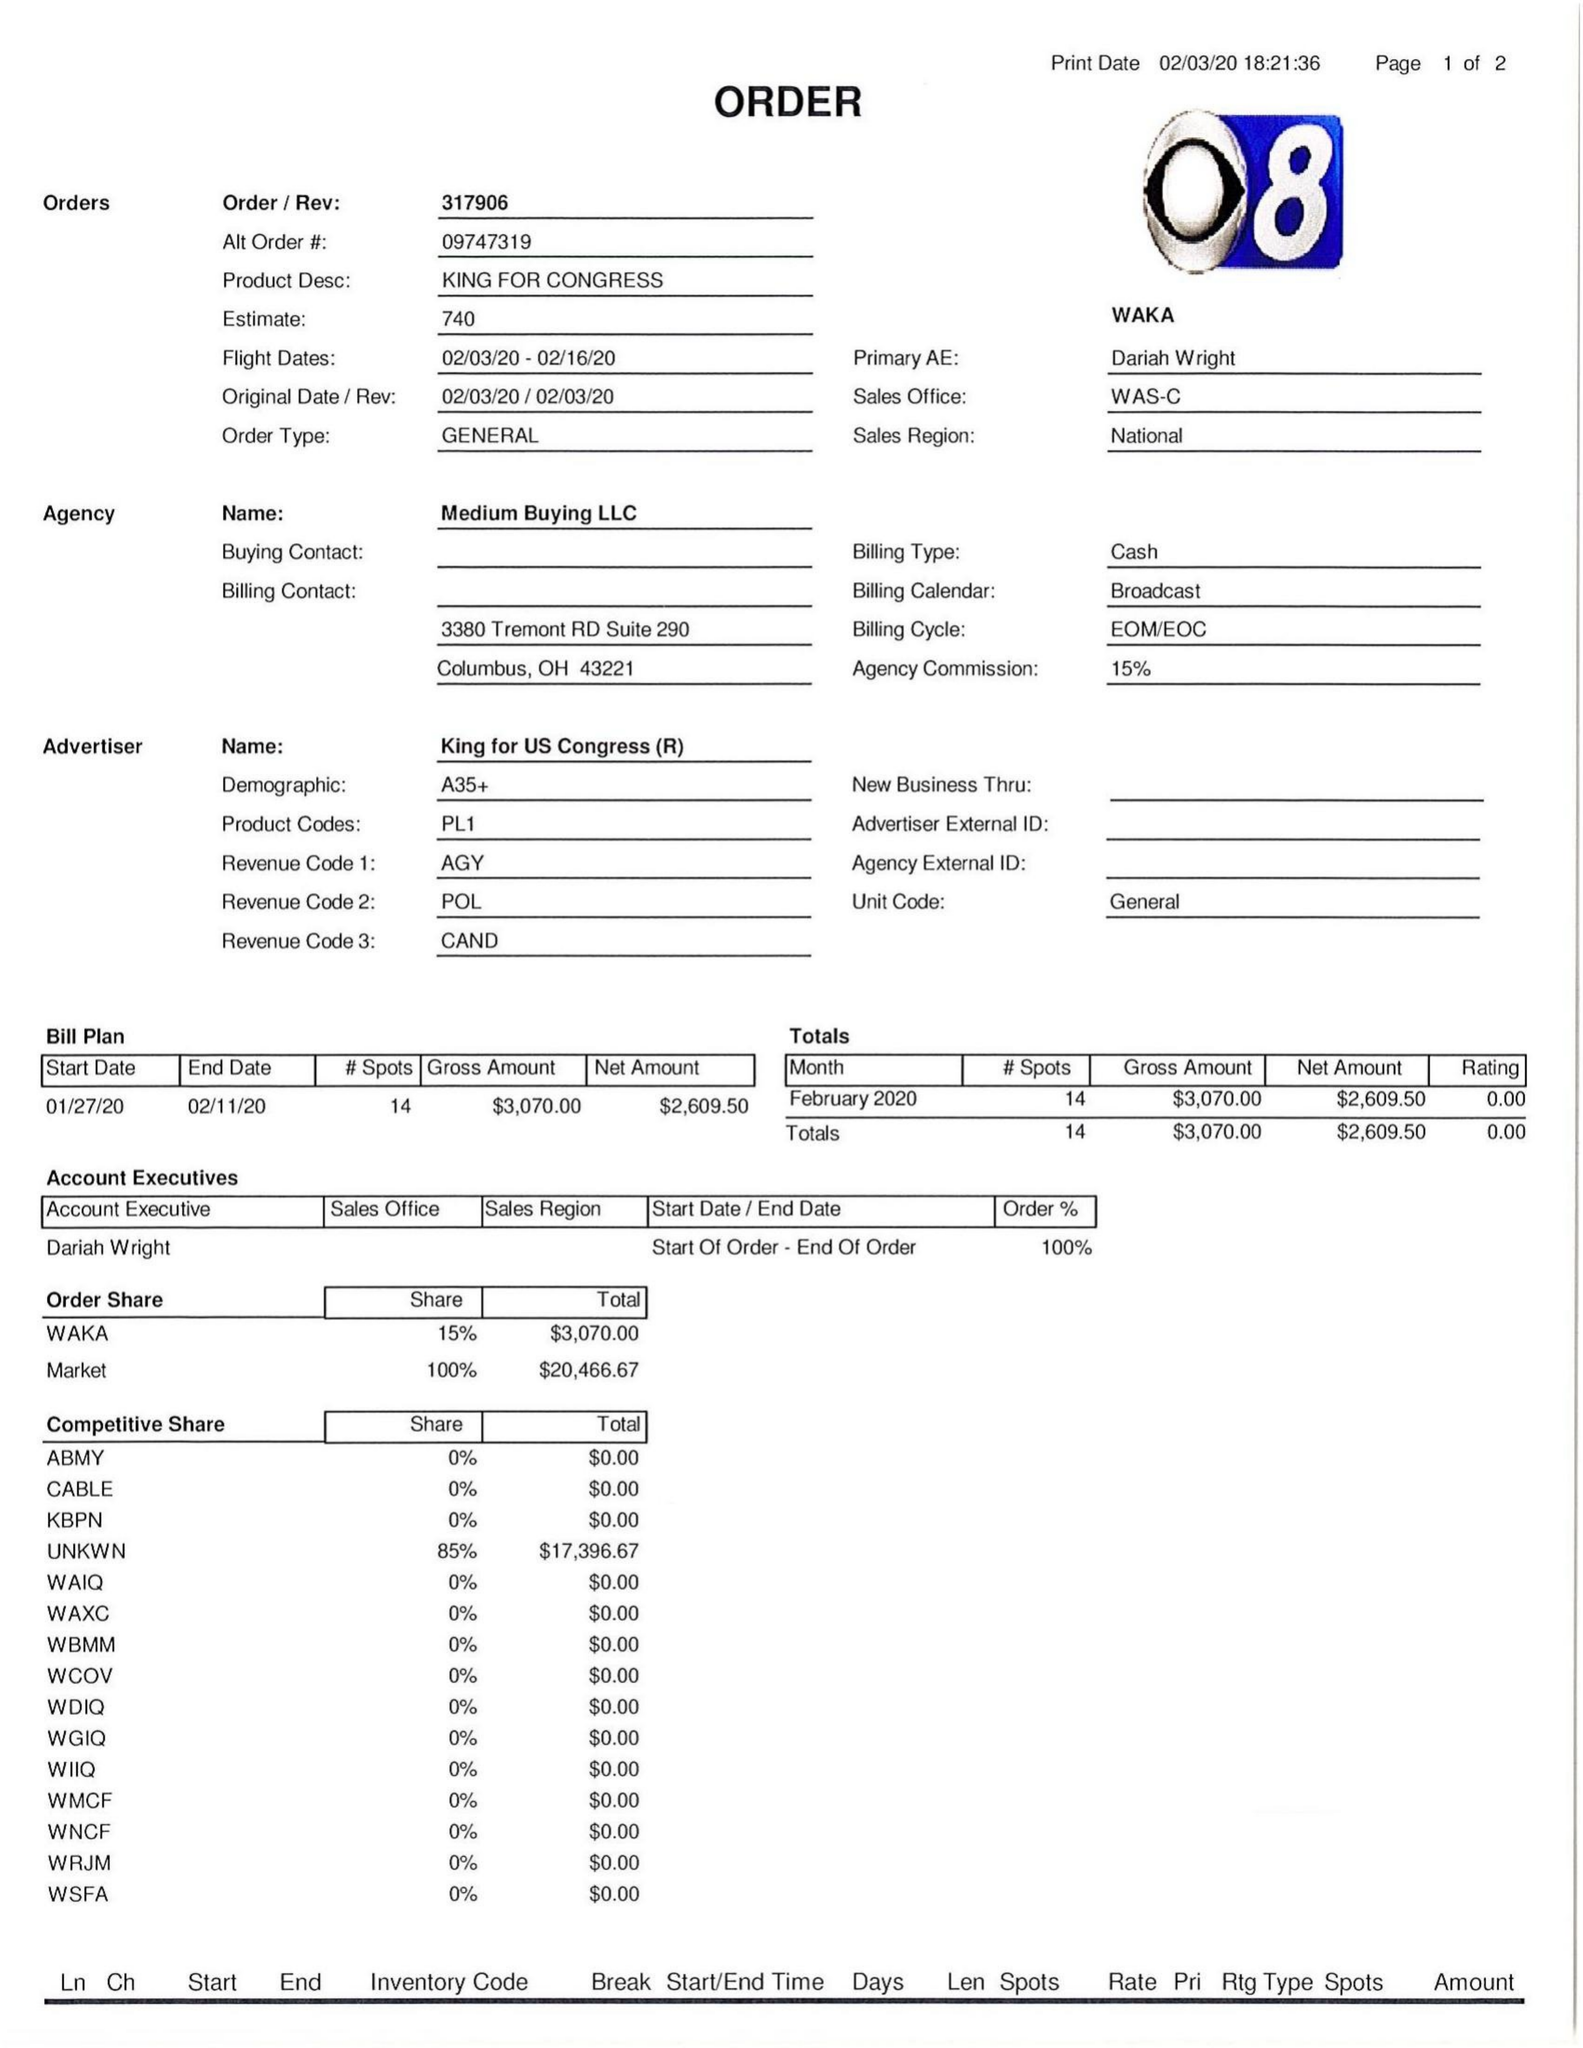What is the value for the flight_from?
Answer the question using a single word or phrase. 02/03/20 